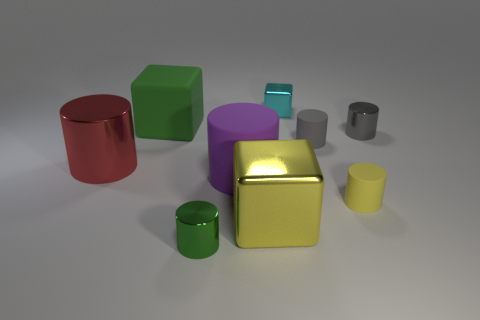Subtract all small metal cylinders. How many cylinders are left? 4 Subtract 4 cylinders. How many cylinders are left? 2 Add 1 tiny yellow rubber cylinders. How many objects exist? 10 Subtract all yellow blocks. How many blocks are left? 2 Subtract all blocks. How many objects are left? 6 Subtract all large purple things. Subtract all rubber cubes. How many objects are left? 7 Add 4 red shiny cylinders. How many red shiny cylinders are left? 5 Add 2 gray rubber things. How many gray rubber things exist? 3 Subtract 0 red balls. How many objects are left? 9 Subtract all yellow blocks. Subtract all red spheres. How many blocks are left? 2 